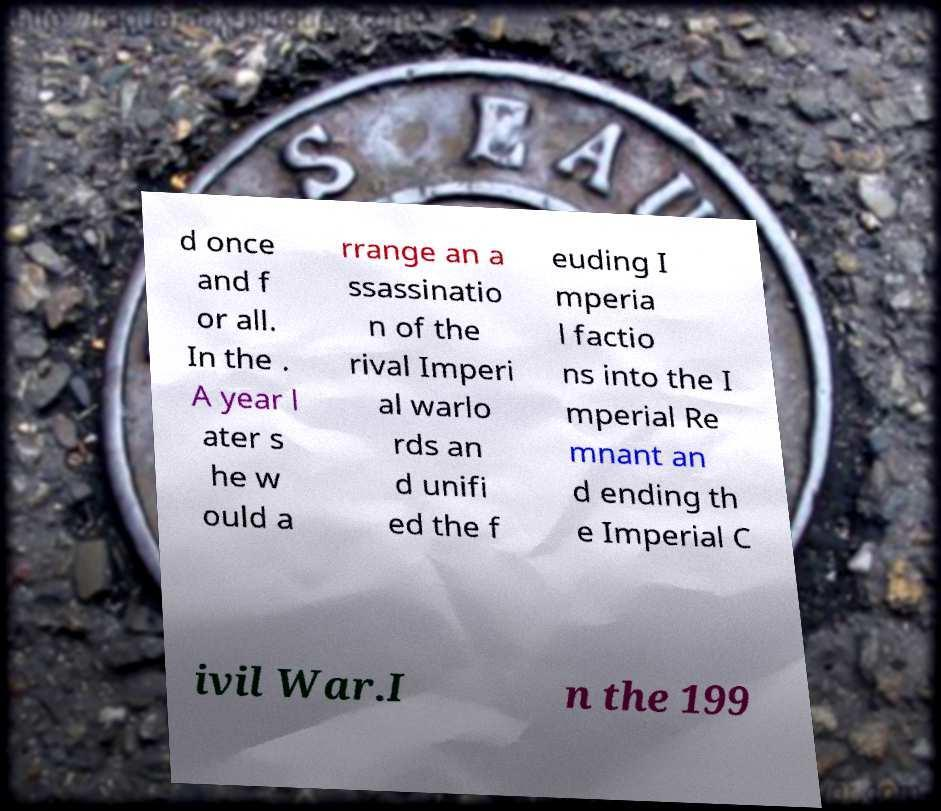Could you assist in decoding the text presented in this image and type it out clearly? d once and f or all. In the . A year l ater s he w ould a rrange an a ssassinatio n of the rival Imperi al warlo rds an d unifi ed the f euding I mperia l factio ns into the I mperial Re mnant an d ending th e Imperial C ivil War.I n the 199 